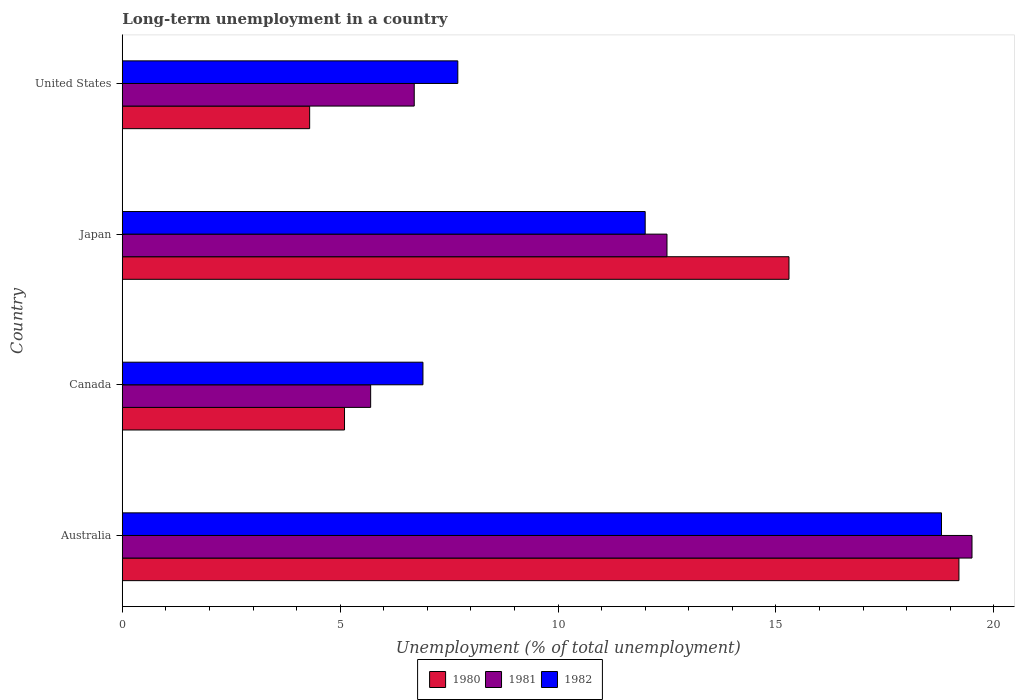How many different coloured bars are there?
Keep it short and to the point. 3. Are the number of bars per tick equal to the number of legend labels?
Your response must be concise. Yes. How many bars are there on the 3rd tick from the bottom?
Your response must be concise. 3. What is the percentage of long-term unemployed population in 1980 in Australia?
Make the answer very short. 19.2. Across all countries, what is the maximum percentage of long-term unemployed population in 1982?
Make the answer very short. 18.8. Across all countries, what is the minimum percentage of long-term unemployed population in 1980?
Provide a short and direct response. 4.3. In which country was the percentage of long-term unemployed population in 1980 maximum?
Offer a terse response. Australia. What is the total percentage of long-term unemployed population in 1982 in the graph?
Offer a terse response. 45.4. What is the difference between the percentage of long-term unemployed population in 1981 in Australia and that in Canada?
Offer a very short reply. 13.8. What is the difference between the percentage of long-term unemployed population in 1980 in United States and the percentage of long-term unemployed population in 1981 in Australia?
Your answer should be compact. -15.2. What is the average percentage of long-term unemployed population in 1981 per country?
Give a very brief answer. 11.1. What is the difference between the percentage of long-term unemployed population in 1981 and percentage of long-term unemployed population in 1980 in Canada?
Offer a very short reply. 0.6. In how many countries, is the percentage of long-term unemployed population in 1982 greater than 17 %?
Provide a short and direct response. 1. What is the ratio of the percentage of long-term unemployed population in 1982 in Canada to that in United States?
Offer a very short reply. 0.9. Is the percentage of long-term unemployed population in 1980 in Australia less than that in United States?
Your answer should be compact. No. What is the difference between the highest and the second highest percentage of long-term unemployed population in 1980?
Offer a very short reply. 3.9. What is the difference between the highest and the lowest percentage of long-term unemployed population in 1980?
Your answer should be very brief. 14.9. What does the 3rd bar from the bottom in Canada represents?
Offer a very short reply. 1982. How many bars are there?
Keep it short and to the point. 12. Are all the bars in the graph horizontal?
Provide a succinct answer. Yes. How many countries are there in the graph?
Offer a very short reply. 4. Does the graph contain any zero values?
Your answer should be very brief. No. Where does the legend appear in the graph?
Make the answer very short. Bottom center. How many legend labels are there?
Make the answer very short. 3. What is the title of the graph?
Offer a terse response. Long-term unemployment in a country. What is the label or title of the X-axis?
Your answer should be compact. Unemployment (% of total unemployment). What is the label or title of the Y-axis?
Make the answer very short. Country. What is the Unemployment (% of total unemployment) in 1980 in Australia?
Make the answer very short. 19.2. What is the Unemployment (% of total unemployment) in 1982 in Australia?
Provide a short and direct response. 18.8. What is the Unemployment (% of total unemployment) of 1980 in Canada?
Your answer should be compact. 5.1. What is the Unemployment (% of total unemployment) of 1981 in Canada?
Offer a very short reply. 5.7. What is the Unemployment (% of total unemployment) of 1982 in Canada?
Make the answer very short. 6.9. What is the Unemployment (% of total unemployment) in 1980 in Japan?
Your answer should be very brief. 15.3. What is the Unemployment (% of total unemployment) in 1981 in Japan?
Keep it short and to the point. 12.5. What is the Unemployment (% of total unemployment) of 1980 in United States?
Your response must be concise. 4.3. What is the Unemployment (% of total unemployment) of 1981 in United States?
Provide a succinct answer. 6.7. What is the Unemployment (% of total unemployment) in 1982 in United States?
Your answer should be very brief. 7.7. Across all countries, what is the maximum Unemployment (% of total unemployment) in 1980?
Offer a terse response. 19.2. Across all countries, what is the maximum Unemployment (% of total unemployment) in 1981?
Provide a short and direct response. 19.5. Across all countries, what is the maximum Unemployment (% of total unemployment) of 1982?
Your answer should be very brief. 18.8. Across all countries, what is the minimum Unemployment (% of total unemployment) of 1980?
Offer a very short reply. 4.3. Across all countries, what is the minimum Unemployment (% of total unemployment) of 1981?
Offer a terse response. 5.7. Across all countries, what is the minimum Unemployment (% of total unemployment) in 1982?
Keep it short and to the point. 6.9. What is the total Unemployment (% of total unemployment) in 1980 in the graph?
Make the answer very short. 43.9. What is the total Unemployment (% of total unemployment) of 1981 in the graph?
Your answer should be compact. 44.4. What is the total Unemployment (% of total unemployment) of 1982 in the graph?
Ensure brevity in your answer.  45.4. What is the difference between the Unemployment (% of total unemployment) in 1982 in Australia and that in Canada?
Keep it short and to the point. 11.9. What is the difference between the Unemployment (% of total unemployment) of 1981 in Australia and that in Japan?
Your answer should be compact. 7. What is the difference between the Unemployment (% of total unemployment) of 1980 in Australia and that in United States?
Your answer should be very brief. 14.9. What is the difference between the Unemployment (% of total unemployment) in 1982 in Australia and that in United States?
Offer a very short reply. 11.1. What is the difference between the Unemployment (% of total unemployment) of 1981 in Canada and that in Japan?
Provide a short and direct response. -6.8. What is the difference between the Unemployment (% of total unemployment) in 1980 in Canada and that in United States?
Offer a very short reply. 0.8. What is the difference between the Unemployment (% of total unemployment) in 1981 in Canada and that in United States?
Your answer should be compact. -1. What is the difference between the Unemployment (% of total unemployment) in 1982 in Canada and that in United States?
Your answer should be very brief. -0.8. What is the difference between the Unemployment (% of total unemployment) in 1980 in Japan and that in United States?
Provide a succinct answer. 11. What is the difference between the Unemployment (% of total unemployment) of 1982 in Japan and that in United States?
Offer a terse response. 4.3. What is the difference between the Unemployment (% of total unemployment) in 1980 in Australia and the Unemployment (% of total unemployment) in 1982 in Canada?
Provide a succinct answer. 12.3. What is the difference between the Unemployment (% of total unemployment) of 1980 in Australia and the Unemployment (% of total unemployment) of 1981 in Japan?
Make the answer very short. 6.7. What is the difference between the Unemployment (% of total unemployment) of 1980 in Australia and the Unemployment (% of total unemployment) of 1982 in Japan?
Ensure brevity in your answer.  7.2. What is the difference between the Unemployment (% of total unemployment) in 1980 in Australia and the Unemployment (% of total unemployment) in 1982 in United States?
Your answer should be very brief. 11.5. What is the difference between the Unemployment (% of total unemployment) of 1981 in Australia and the Unemployment (% of total unemployment) of 1982 in United States?
Your response must be concise. 11.8. What is the difference between the Unemployment (% of total unemployment) of 1980 in Canada and the Unemployment (% of total unemployment) of 1981 in Japan?
Provide a succinct answer. -7.4. What is the difference between the Unemployment (% of total unemployment) in 1980 in Canada and the Unemployment (% of total unemployment) in 1982 in Japan?
Offer a very short reply. -6.9. What is the difference between the Unemployment (% of total unemployment) in 1981 in Canada and the Unemployment (% of total unemployment) in 1982 in Japan?
Keep it short and to the point. -6.3. What is the difference between the Unemployment (% of total unemployment) in 1980 in Canada and the Unemployment (% of total unemployment) in 1982 in United States?
Ensure brevity in your answer.  -2.6. What is the difference between the Unemployment (% of total unemployment) in 1981 in Canada and the Unemployment (% of total unemployment) in 1982 in United States?
Offer a very short reply. -2. What is the difference between the Unemployment (% of total unemployment) in 1980 in Japan and the Unemployment (% of total unemployment) in 1981 in United States?
Your response must be concise. 8.6. What is the difference between the Unemployment (% of total unemployment) in 1981 in Japan and the Unemployment (% of total unemployment) in 1982 in United States?
Make the answer very short. 4.8. What is the average Unemployment (% of total unemployment) of 1980 per country?
Offer a terse response. 10.97. What is the average Unemployment (% of total unemployment) of 1982 per country?
Offer a terse response. 11.35. What is the difference between the Unemployment (% of total unemployment) of 1980 and Unemployment (% of total unemployment) of 1981 in Australia?
Provide a short and direct response. -0.3. What is the difference between the Unemployment (% of total unemployment) in 1981 and Unemployment (% of total unemployment) in 1982 in Canada?
Provide a succinct answer. -1.2. What is the difference between the Unemployment (% of total unemployment) of 1980 and Unemployment (% of total unemployment) of 1982 in Japan?
Your answer should be compact. 3.3. What is the difference between the Unemployment (% of total unemployment) of 1981 and Unemployment (% of total unemployment) of 1982 in Japan?
Provide a succinct answer. 0.5. What is the difference between the Unemployment (% of total unemployment) of 1980 and Unemployment (% of total unemployment) of 1982 in United States?
Keep it short and to the point. -3.4. What is the difference between the Unemployment (% of total unemployment) of 1981 and Unemployment (% of total unemployment) of 1982 in United States?
Your answer should be very brief. -1. What is the ratio of the Unemployment (% of total unemployment) in 1980 in Australia to that in Canada?
Your response must be concise. 3.76. What is the ratio of the Unemployment (% of total unemployment) in 1981 in Australia to that in Canada?
Your answer should be very brief. 3.42. What is the ratio of the Unemployment (% of total unemployment) of 1982 in Australia to that in Canada?
Offer a terse response. 2.72. What is the ratio of the Unemployment (% of total unemployment) in 1980 in Australia to that in Japan?
Offer a very short reply. 1.25. What is the ratio of the Unemployment (% of total unemployment) of 1981 in Australia to that in Japan?
Your answer should be compact. 1.56. What is the ratio of the Unemployment (% of total unemployment) in 1982 in Australia to that in Japan?
Your answer should be compact. 1.57. What is the ratio of the Unemployment (% of total unemployment) in 1980 in Australia to that in United States?
Your answer should be compact. 4.47. What is the ratio of the Unemployment (% of total unemployment) in 1981 in Australia to that in United States?
Make the answer very short. 2.91. What is the ratio of the Unemployment (% of total unemployment) in 1982 in Australia to that in United States?
Ensure brevity in your answer.  2.44. What is the ratio of the Unemployment (% of total unemployment) in 1981 in Canada to that in Japan?
Offer a terse response. 0.46. What is the ratio of the Unemployment (% of total unemployment) of 1982 in Canada to that in Japan?
Offer a terse response. 0.57. What is the ratio of the Unemployment (% of total unemployment) in 1980 in Canada to that in United States?
Your response must be concise. 1.19. What is the ratio of the Unemployment (% of total unemployment) in 1981 in Canada to that in United States?
Make the answer very short. 0.85. What is the ratio of the Unemployment (% of total unemployment) of 1982 in Canada to that in United States?
Make the answer very short. 0.9. What is the ratio of the Unemployment (% of total unemployment) in 1980 in Japan to that in United States?
Provide a succinct answer. 3.56. What is the ratio of the Unemployment (% of total unemployment) in 1981 in Japan to that in United States?
Your answer should be compact. 1.87. What is the ratio of the Unemployment (% of total unemployment) of 1982 in Japan to that in United States?
Ensure brevity in your answer.  1.56. What is the difference between the highest and the second highest Unemployment (% of total unemployment) in 1981?
Provide a short and direct response. 7. What is the difference between the highest and the second highest Unemployment (% of total unemployment) in 1982?
Your answer should be very brief. 6.8. What is the difference between the highest and the lowest Unemployment (% of total unemployment) in 1980?
Keep it short and to the point. 14.9. What is the difference between the highest and the lowest Unemployment (% of total unemployment) in 1981?
Provide a short and direct response. 13.8. 